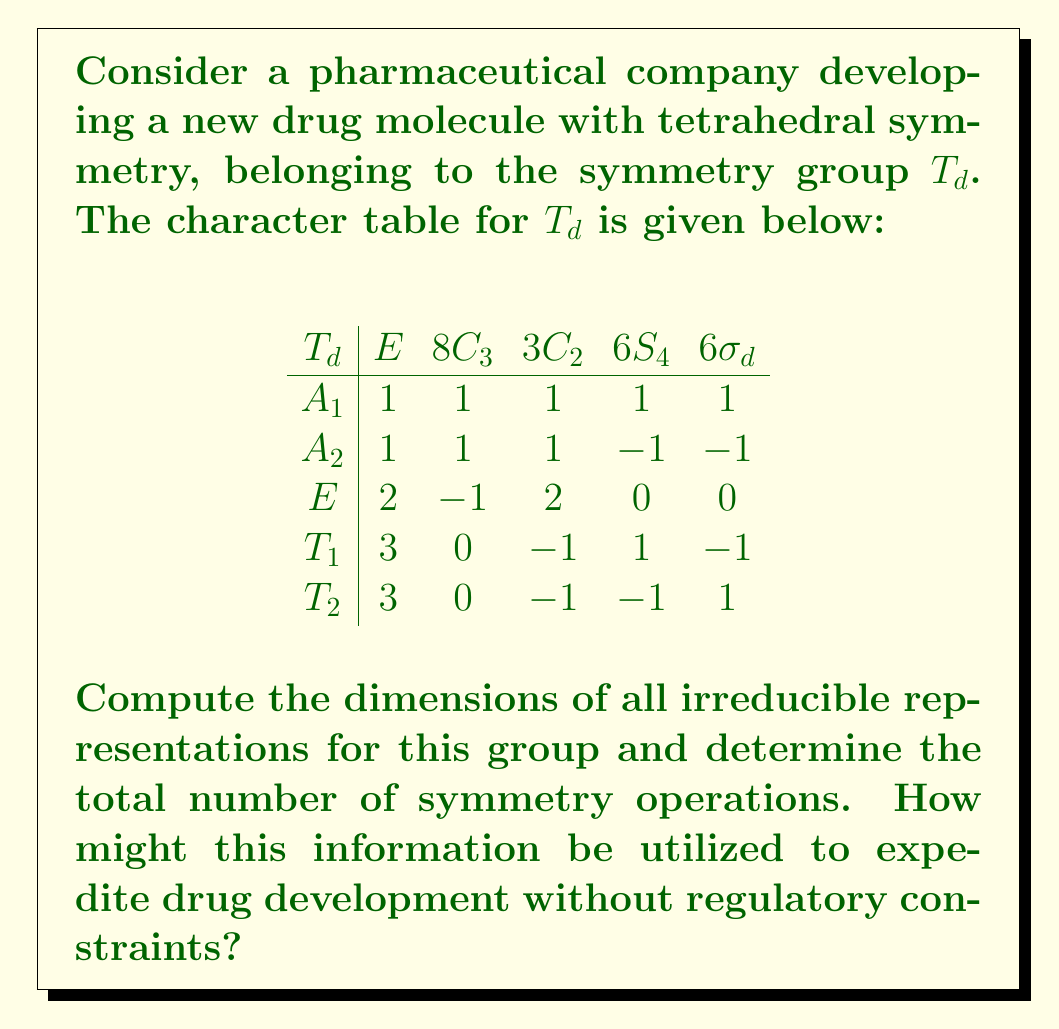Teach me how to tackle this problem. To solve this problem, we'll follow these steps:

1) The dimensions of irreducible representations are given by the characters in the first column (under E) of the character table. This is because E represents the identity element, and the character of the identity element in a representation is equal to its dimension.

   $A_1$: dimension = 1
   $A_2$: dimension = 1
   $E$: dimension = 2
   $T_1$: dimension = 3
   $T_2$: dimension = 3

2) To find the total number of symmetry operations, we sum the number of elements in each conjugacy class (the numbers above each column):

   $|T_d| = 1 + 8 + 3 + 6 + 6 = 24$

3) We can verify this using the orthogonality theorem of characters, which states:

   $\sum_{i} d_i^2 = |G|$

   where $d_i$ are the dimensions of irreducible representations and $|G|$ is the order of the group.

   $1^2 + 1^2 + 2^2 + 3^2 + 3^2 = 1 + 1 + 4 + 9 + 9 = 24$

This information can be used to expedite drug development by:

a) Predicting molecular properties based on symmetry without extensive testing.
b) Optimizing computational models for drug-receptor interactions.
c) Designing more efficient screening processes for potential drug candidates.
d) Reducing the number of experiments needed by leveraging symmetry-based predictions.

Without regulatory constraints, researchers could rapidly test and iterate on drug designs using these symmetry principles, potentially leading to faster discoveries and breakthroughs in pharmaceutical development.
Answer: Dimensions: 1, 1, 2, 3, 3. Total symmetry operations: 24. 